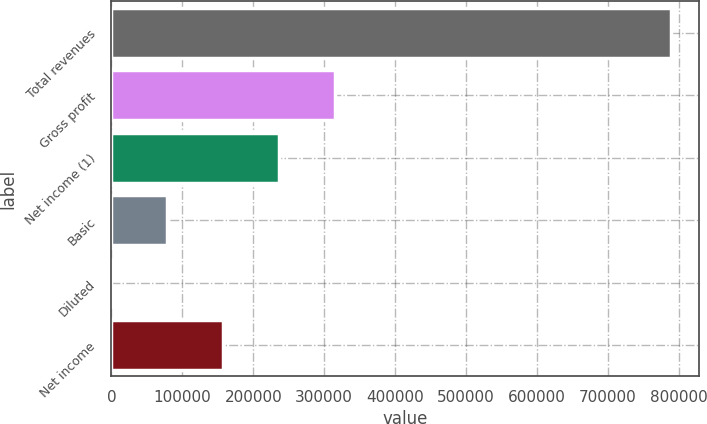<chart> <loc_0><loc_0><loc_500><loc_500><bar_chart><fcel>Total revenues<fcel>Gross profit<fcel>Net income (1)<fcel>Basic<fcel>Diluted<fcel>Net income<nl><fcel>788610<fcel>315445<fcel>236584<fcel>78862.1<fcel>1.26<fcel>157723<nl></chart> 